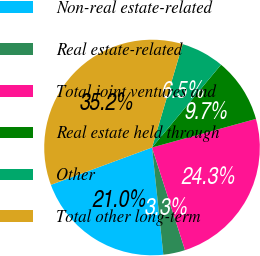<chart> <loc_0><loc_0><loc_500><loc_500><pie_chart><fcel>Non-real estate-related<fcel>Real estate-related<fcel>Total joint ventures and<fcel>Real estate held through<fcel>Other<fcel>Total other long-term<nl><fcel>21.04%<fcel>3.28%<fcel>24.32%<fcel>9.67%<fcel>6.47%<fcel>35.21%<nl></chart> 